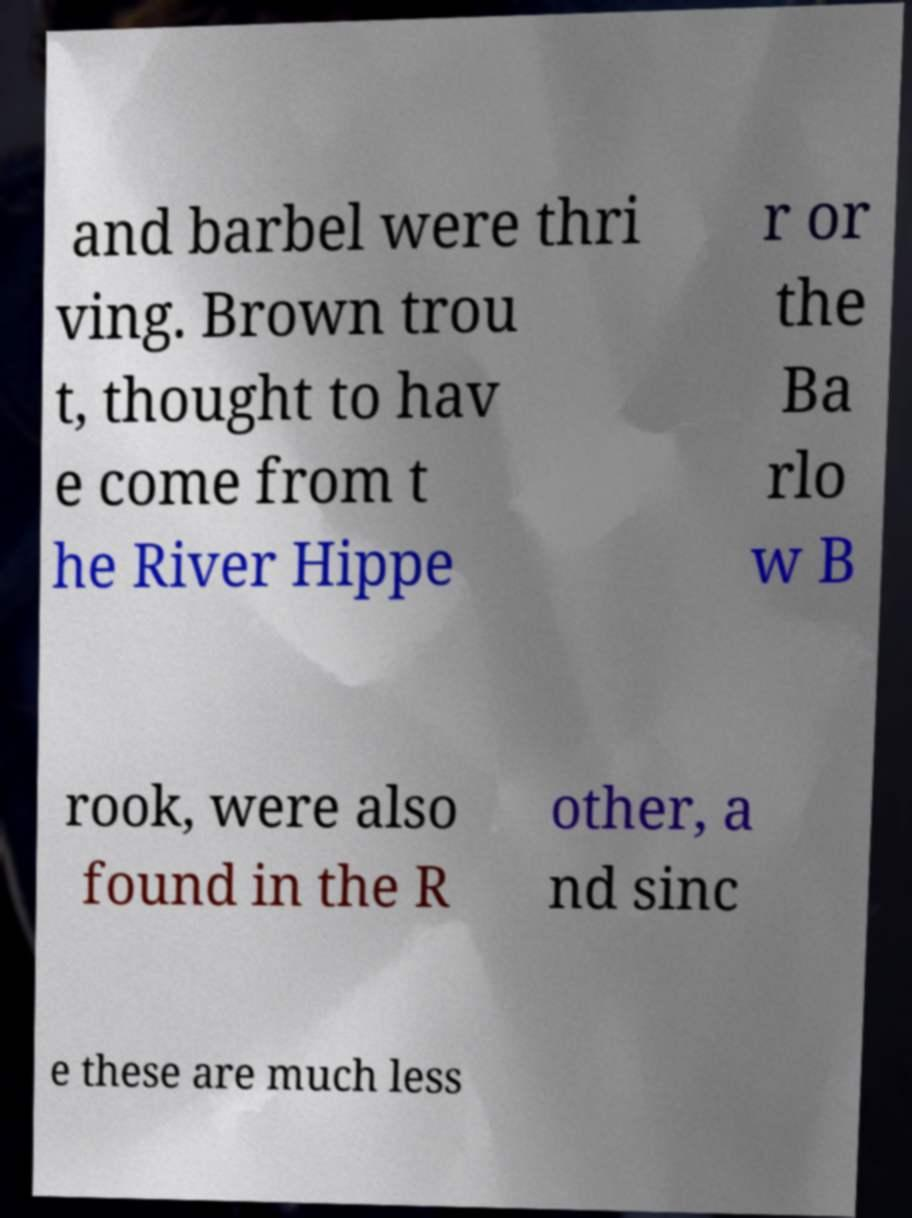Could you assist in decoding the text presented in this image and type it out clearly? and barbel were thri ving. Brown trou t, thought to hav e come from t he River Hippe r or the Ba rlo w B rook, were also found in the R other, a nd sinc e these are much less 